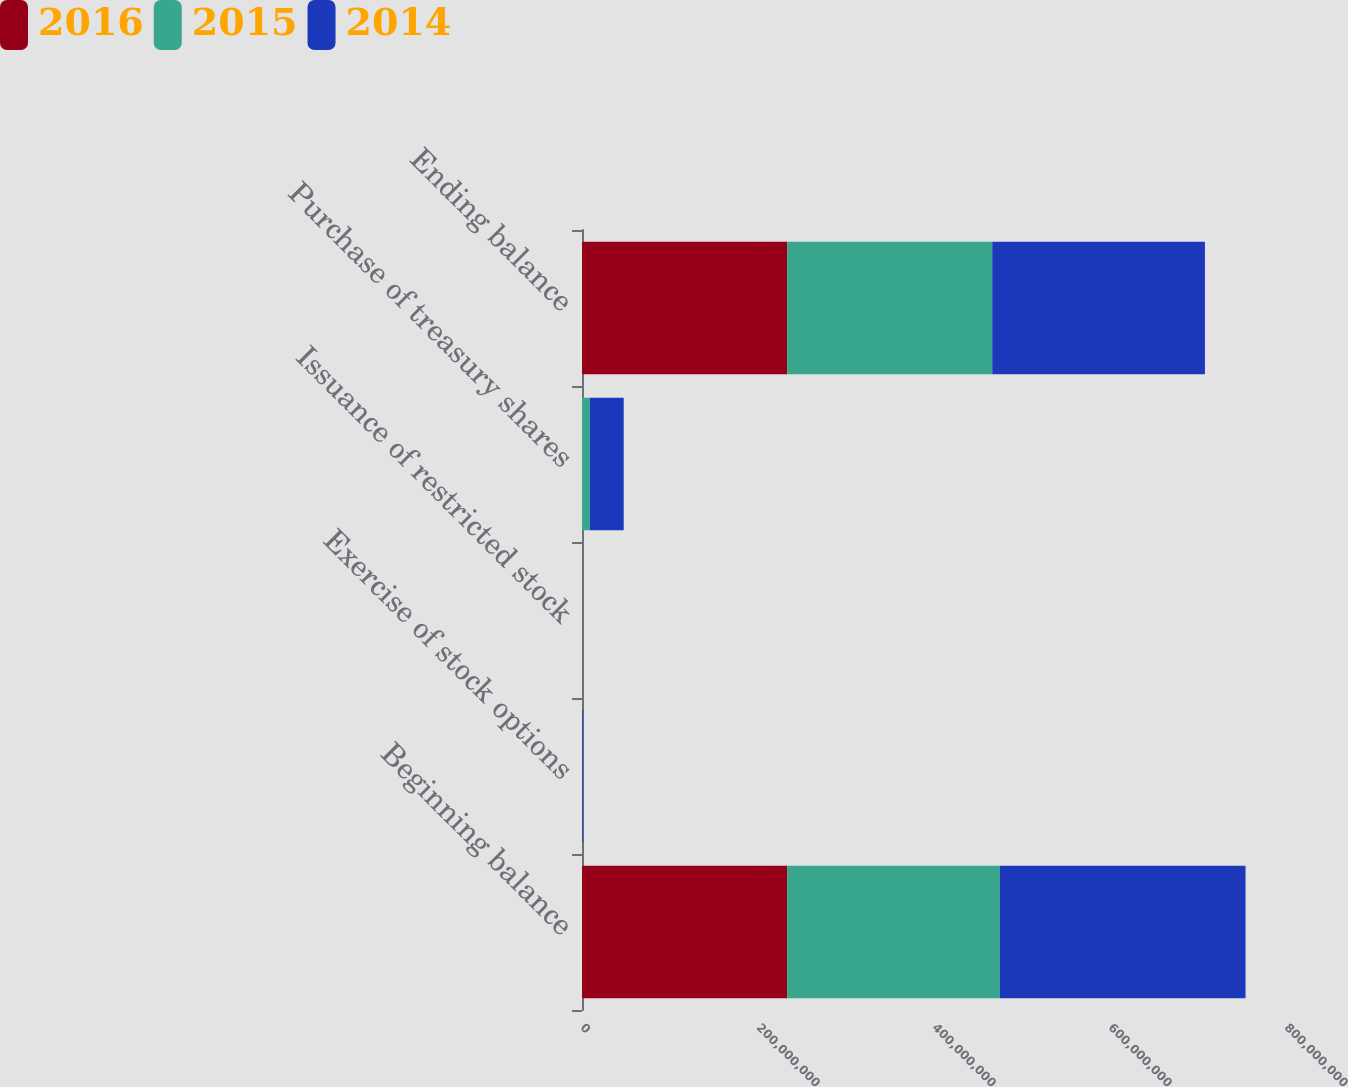Convert chart to OTSL. <chart><loc_0><loc_0><loc_500><loc_500><stacked_bar_chart><ecel><fcel>Beginning balance<fcel>Exercise of stock options<fcel>Issuance of restricted stock<fcel>Purchase of treasury shares<fcel>Ending balance<nl><fcel>2016<fcel>2.33082e+08<fcel>17600<fcel>44941<fcel>19928<fcel>2.33114e+08<nl><fcel>2015<fcel>2.41673e+08<fcel>274705<fcel>40673<fcel>8.90687e+06<fcel>2.33082e+08<nl><fcel>2014<fcel>2.79241e+08<fcel>942560<fcel>20875<fcel>3.84657e+07<fcel>2.41673e+08<nl></chart> 